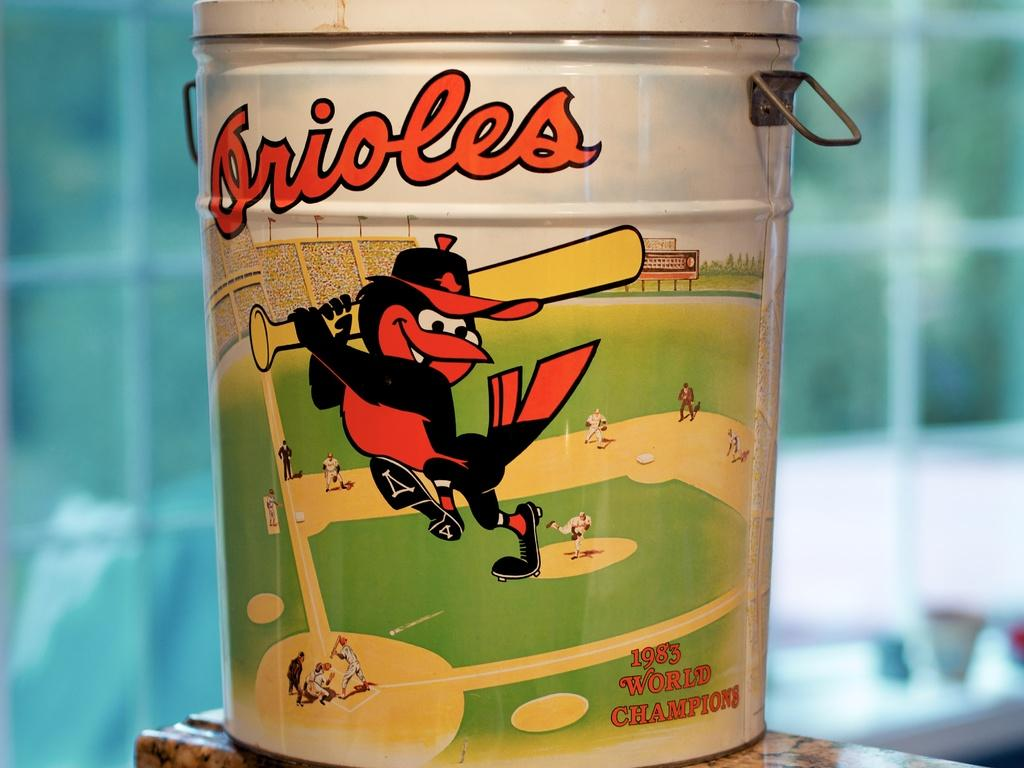<image>
Describe the image concisely. A can with the Orioles mascot for the 1983 world championship. 